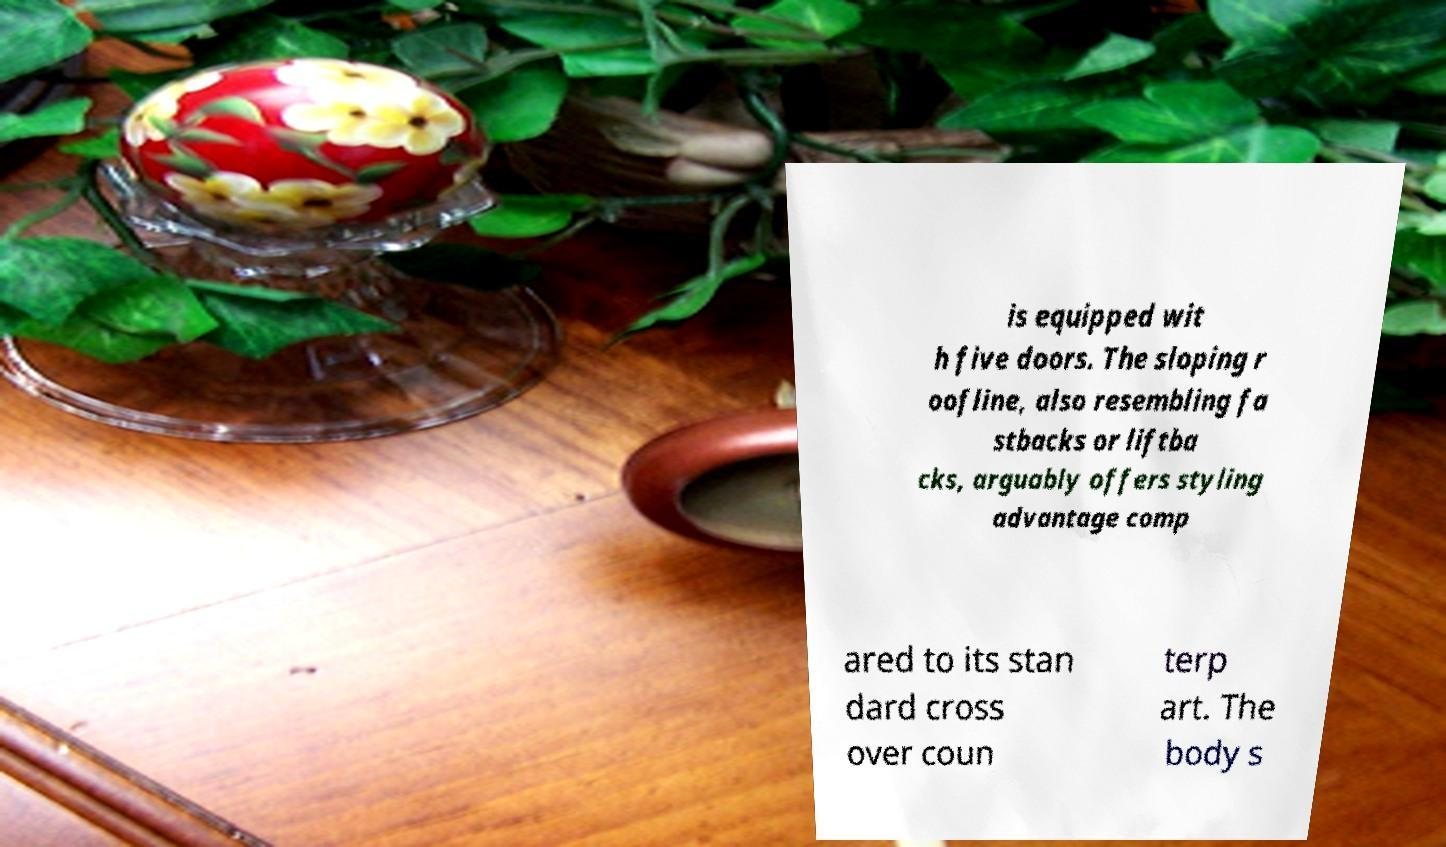I need the written content from this picture converted into text. Can you do that? is equipped wit h five doors. The sloping r oofline, also resembling fa stbacks or liftba cks, arguably offers styling advantage comp ared to its stan dard cross over coun terp art. The body s 